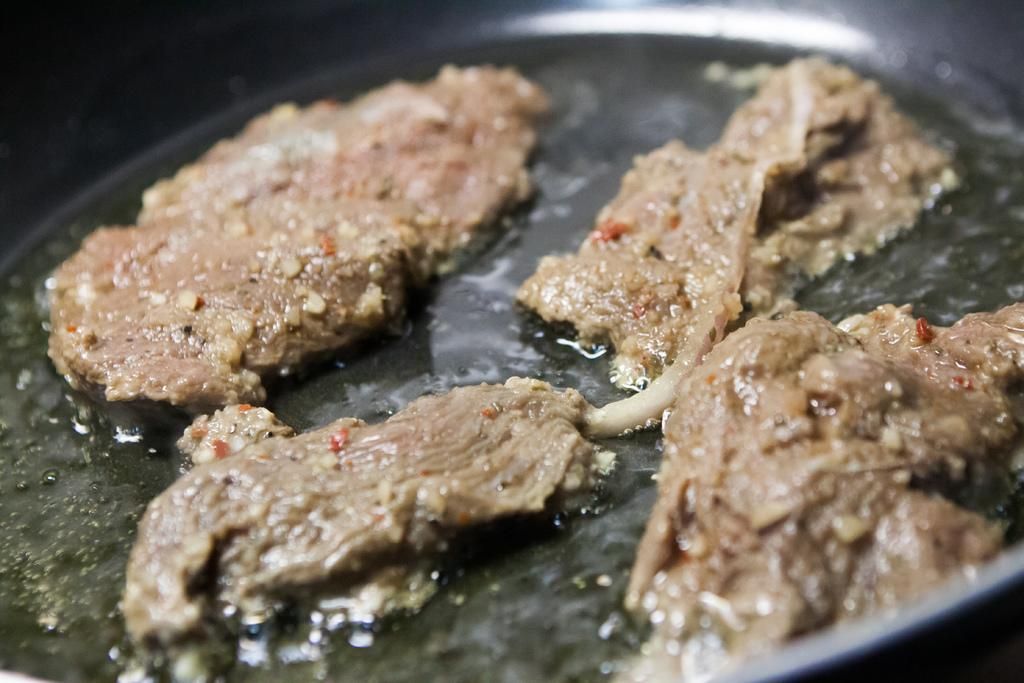What is present in the pan in the image? There is food in the pan in the image. What political figure is responsible for the food being cooked in the pan in the image? There is no political figure mentioned or depicted in the image, and the food's preparation is not attributed to any specific person. 